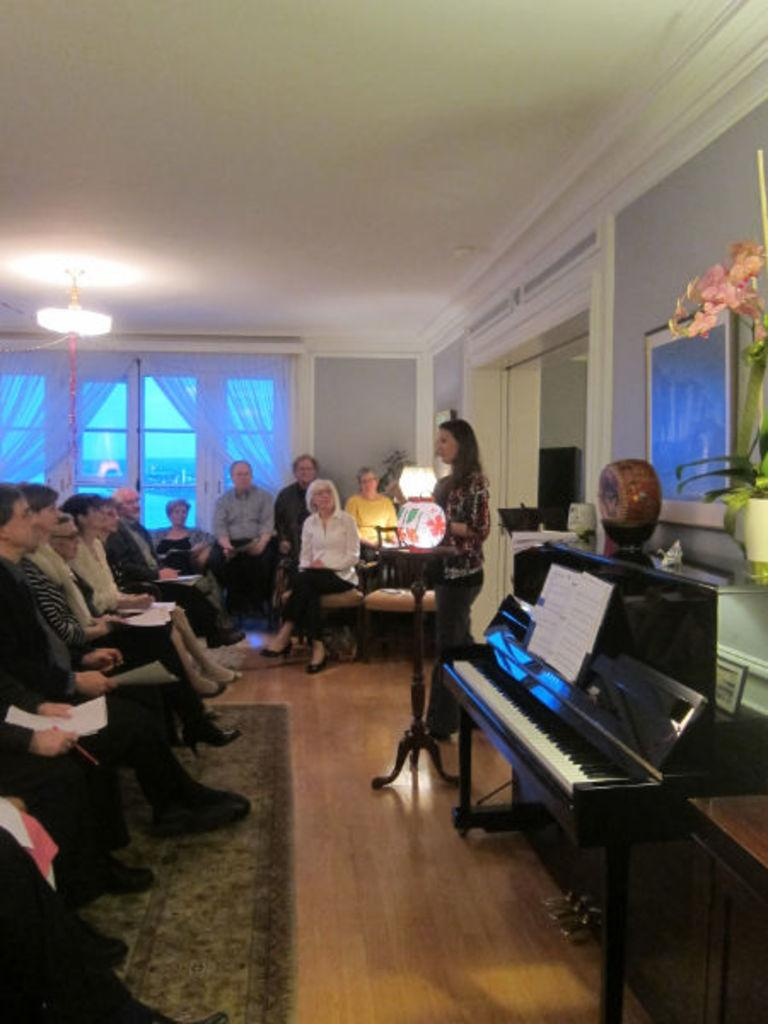What are the people in the image doing? The people in the image are sitting on chairs and holding papers. What is the woman in the image doing? The woman is talking. What object is near the woman? There is a piano near the woman. What type of engine is being used to power the trousers in the image? There are no trousers or engines present in the image. How many hooks can be seen attached to the piano in the image? There are no hooks visible on the piano in the image. 